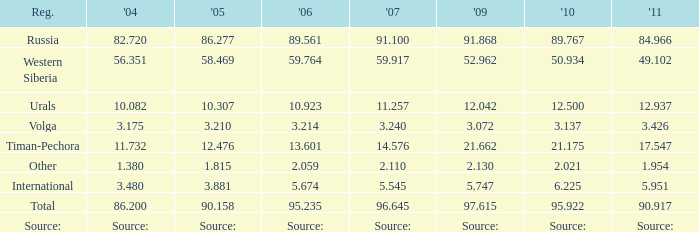Parse the table in full. {'header': ['Reg.', "'04", "'05", "'06", "'07", "'09", "'10", "'11"], 'rows': [['Russia', '82.720', '86.277', '89.561', '91.100', '91.868', '89.767', '84.966'], ['Western Siberia', '56.351', '58.469', '59.764', '59.917', '52.962', '50.934', '49.102'], ['Urals', '10.082', '10.307', '10.923', '11.257', '12.042', '12.500', '12.937'], ['Volga', '3.175', '3.210', '3.214', '3.240', '3.072', '3.137', '3.426'], ['Timan-Pechora', '11.732', '12.476', '13.601', '14.576', '21.662', '21.175', '17.547'], ['Other', '1.380', '1.815', '2.059', '2.110', '2.130', '2.021', '1.954'], ['International', '3.480', '3.881', '5.674', '5.545', '5.747', '6.225', '5.951'], ['Total', '86.200', '90.158', '95.235', '96.645', '97.615', '95.922', '90.917'], ['Source:', 'Source:', 'Source:', 'Source:', 'Source:', 'Source:', 'Source:', 'Source:']]} What is the 2005 Lukoil oil prodroduction when in 2007 oil production 5.545 million tonnes? 3.881. 